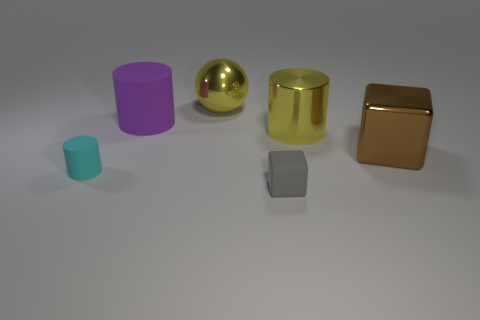Add 1 gray rubber things. How many objects exist? 7 Subtract all blocks. How many objects are left? 4 Add 5 cyan matte cylinders. How many cyan matte cylinders are left? 6 Add 4 tiny blue matte things. How many tiny blue matte things exist? 4 Subtract 0 blue spheres. How many objects are left? 6 Subtract all brown metallic objects. Subtract all tiny rubber cylinders. How many objects are left? 4 